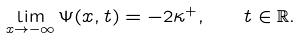<formula> <loc_0><loc_0><loc_500><loc_500>\lim _ { x \to - \infty } \Psi ( x , t ) = - 2 \kappa ^ { + } , \quad t \in { \mathbb { R } } .</formula> 